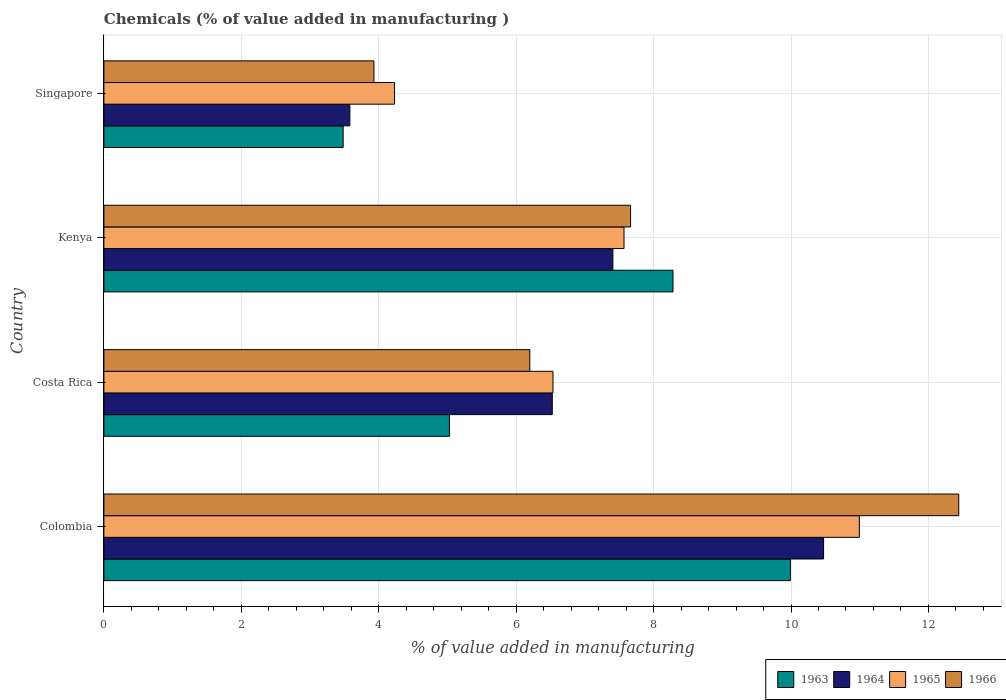How many bars are there on the 4th tick from the top?
Offer a terse response. 4. What is the label of the 2nd group of bars from the top?
Ensure brevity in your answer.  Kenya. In how many cases, is the number of bars for a given country not equal to the number of legend labels?
Your response must be concise. 0. What is the value added in manufacturing chemicals in 1965 in Colombia?
Offer a very short reply. 10.99. Across all countries, what is the maximum value added in manufacturing chemicals in 1964?
Ensure brevity in your answer.  10.47. Across all countries, what is the minimum value added in manufacturing chemicals in 1966?
Your answer should be compact. 3.93. In which country was the value added in manufacturing chemicals in 1965 maximum?
Your answer should be compact. Colombia. In which country was the value added in manufacturing chemicals in 1964 minimum?
Your response must be concise. Singapore. What is the total value added in manufacturing chemicals in 1964 in the graph?
Your answer should be very brief. 27.99. What is the difference between the value added in manufacturing chemicals in 1965 in Costa Rica and that in Singapore?
Your answer should be very brief. 2.31. What is the difference between the value added in manufacturing chemicals in 1963 in Kenya and the value added in manufacturing chemicals in 1965 in Singapore?
Offer a terse response. 4.05. What is the average value added in manufacturing chemicals in 1965 per country?
Ensure brevity in your answer.  7.33. What is the difference between the value added in manufacturing chemicals in 1963 and value added in manufacturing chemicals in 1965 in Kenya?
Ensure brevity in your answer.  0.71. In how many countries, is the value added in manufacturing chemicals in 1966 greater than 2.8 %?
Give a very brief answer. 4. What is the ratio of the value added in manufacturing chemicals in 1964 in Colombia to that in Kenya?
Offer a very short reply. 1.41. Is the value added in manufacturing chemicals in 1963 in Colombia less than that in Costa Rica?
Offer a very short reply. No. Is the difference between the value added in manufacturing chemicals in 1963 in Costa Rica and Singapore greater than the difference between the value added in manufacturing chemicals in 1965 in Costa Rica and Singapore?
Provide a succinct answer. No. What is the difference between the highest and the second highest value added in manufacturing chemicals in 1965?
Offer a very short reply. 3.43. What is the difference between the highest and the lowest value added in manufacturing chemicals in 1963?
Keep it short and to the point. 6.51. Is the sum of the value added in manufacturing chemicals in 1963 in Costa Rica and Kenya greater than the maximum value added in manufacturing chemicals in 1966 across all countries?
Give a very brief answer. Yes. Is it the case that in every country, the sum of the value added in manufacturing chemicals in 1965 and value added in manufacturing chemicals in 1963 is greater than the sum of value added in manufacturing chemicals in 1966 and value added in manufacturing chemicals in 1964?
Provide a succinct answer. No. What does the 1st bar from the top in Singapore represents?
Make the answer very short. 1966. What does the 2nd bar from the bottom in Kenya represents?
Offer a very short reply. 1964. Is it the case that in every country, the sum of the value added in manufacturing chemicals in 1966 and value added in manufacturing chemicals in 1964 is greater than the value added in manufacturing chemicals in 1965?
Your response must be concise. Yes. How many bars are there?
Ensure brevity in your answer.  16. Are all the bars in the graph horizontal?
Your response must be concise. Yes. How many countries are there in the graph?
Make the answer very short. 4. What is the difference between two consecutive major ticks on the X-axis?
Offer a very short reply. 2. Are the values on the major ticks of X-axis written in scientific E-notation?
Make the answer very short. No. Does the graph contain grids?
Make the answer very short. Yes. How many legend labels are there?
Provide a short and direct response. 4. How are the legend labels stacked?
Your response must be concise. Horizontal. What is the title of the graph?
Make the answer very short. Chemicals (% of value added in manufacturing ). What is the label or title of the X-axis?
Your answer should be very brief. % of value added in manufacturing. What is the % of value added in manufacturing of 1963 in Colombia?
Offer a very short reply. 9.99. What is the % of value added in manufacturing in 1964 in Colombia?
Your response must be concise. 10.47. What is the % of value added in manufacturing in 1965 in Colombia?
Your response must be concise. 10.99. What is the % of value added in manufacturing of 1966 in Colombia?
Offer a terse response. 12.44. What is the % of value added in manufacturing of 1963 in Costa Rica?
Offer a very short reply. 5.03. What is the % of value added in manufacturing of 1964 in Costa Rica?
Provide a succinct answer. 6.53. What is the % of value added in manufacturing in 1965 in Costa Rica?
Your answer should be compact. 6.54. What is the % of value added in manufacturing in 1966 in Costa Rica?
Provide a short and direct response. 6.2. What is the % of value added in manufacturing in 1963 in Kenya?
Give a very brief answer. 8.28. What is the % of value added in manufacturing of 1964 in Kenya?
Provide a short and direct response. 7.41. What is the % of value added in manufacturing of 1965 in Kenya?
Offer a very short reply. 7.57. What is the % of value added in manufacturing in 1966 in Kenya?
Keep it short and to the point. 7.67. What is the % of value added in manufacturing of 1963 in Singapore?
Make the answer very short. 3.48. What is the % of value added in manufacturing of 1964 in Singapore?
Your answer should be compact. 3.58. What is the % of value added in manufacturing in 1965 in Singapore?
Give a very brief answer. 4.23. What is the % of value added in manufacturing in 1966 in Singapore?
Your answer should be compact. 3.93. Across all countries, what is the maximum % of value added in manufacturing of 1963?
Provide a succinct answer. 9.99. Across all countries, what is the maximum % of value added in manufacturing in 1964?
Your response must be concise. 10.47. Across all countries, what is the maximum % of value added in manufacturing in 1965?
Your answer should be very brief. 10.99. Across all countries, what is the maximum % of value added in manufacturing in 1966?
Your answer should be compact. 12.44. Across all countries, what is the minimum % of value added in manufacturing of 1963?
Keep it short and to the point. 3.48. Across all countries, what is the minimum % of value added in manufacturing in 1964?
Keep it short and to the point. 3.58. Across all countries, what is the minimum % of value added in manufacturing in 1965?
Provide a short and direct response. 4.23. Across all countries, what is the minimum % of value added in manufacturing in 1966?
Keep it short and to the point. 3.93. What is the total % of value added in manufacturing in 1963 in the graph?
Make the answer very short. 26.79. What is the total % of value added in manufacturing in 1964 in the graph?
Make the answer very short. 27.99. What is the total % of value added in manufacturing in 1965 in the graph?
Offer a very short reply. 29.33. What is the total % of value added in manufacturing in 1966 in the graph?
Ensure brevity in your answer.  30.23. What is the difference between the % of value added in manufacturing of 1963 in Colombia and that in Costa Rica?
Ensure brevity in your answer.  4.96. What is the difference between the % of value added in manufacturing of 1964 in Colombia and that in Costa Rica?
Offer a terse response. 3.95. What is the difference between the % of value added in manufacturing of 1965 in Colombia and that in Costa Rica?
Your response must be concise. 4.46. What is the difference between the % of value added in manufacturing of 1966 in Colombia and that in Costa Rica?
Give a very brief answer. 6.24. What is the difference between the % of value added in manufacturing of 1963 in Colombia and that in Kenya?
Your answer should be very brief. 1.71. What is the difference between the % of value added in manufacturing of 1964 in Colombia and that in Kenya?
Provide a short and direct response. 3.07. What is the difference between the % of value added in manufacturing in 1965 in Colombia and that in Kenya?
Your answer should be compact. 3.43. What is the difference between the % of value added in manufacturing of 1966 in Colombia and that in Kenya?
Make the answer very short. 4.78. What is the difference between the % of value added in manufacturing of 1963 in Colombia and that in Singapore?
Give a very brief answer. 6.51. What is the difference between the % of value added in manufacturing of 1964 in Colombia and that in Singapore?
Your answer should be very brief. 6.89. What is the difference between the % of value added in manufacturing in 1965 in Colombia and that in Singapore?
Your response must be concise. 6.76. What is the difference between the % of value added in manufacturing in 1966 in Colombia and that in Singapore?
Provide a succinct answer. 8.51. What is the difference between the % of value added in manufacturing of 1963 in Costa Rica and that in Kenya?
Offer a terse response. -3.25. What is the difference between the % of value added in manufacturing in 1964 in Costa Rica and that in Kenya?
Offer a very short reply. -0.88. What is the difference between the % of value added in manufacturing of 1965 in Costa Rica and that in Kenya?
Provide a succinct answer. -1.03. What is the difference between the % of value added in manufacturing in 1966 in Costa Rica and that in Kenya?
Provide a short and direct response. -1.47. What is the difference between the % of value added in manufacturing in 1963 in Costa Rica and that in Singapore?
Ensure brevity in your answer.  1.55. What is the difference between the % of value added in manufacturing in 1964 in Costa Rica and that in Singapore?
Offer a terse response. 2.95. What is the difference between the % of value added in manufacturing of 1965 in Costa Rica and that in Singapore?
Provide a short and direct response. 2.31. What is the difference between the % of value added in manufacturing of 1966 in Costa Rica and that in Singapore?
Ensure brevity in your answer.  2.27. What is the difference between the % of value added in manufacturing of 1963 in Kenya and that in Singapore?
Your answer should be compact. 4.8. What is the difference between the % of value added in manufacturing in 1964 in Kenya and that in Singapore?
Ensure brevity in your answer.  3.83. What is the difference between the % of value added in manufacturing of 1965 in Kenya and that in Singapore?
Your response must be concise. 3.34. What is the difference between the % of value added in manufacturing in 1966 in Kenya and that in Singapore?
Your response must be concise. 3.74. What is the difference between the % of value added in manufacturing of 1963 in Colombia and the % of value added in manufacturing of 1964 in Costa Rica?
Your response must be concise. 3.47. What is the difference between the % of value added in manufacturing of 1963 in Colombia and the % of value added in manufacturing of 1965 in Costa Rica?
Your answer should be very brief. 3.46. What is the difference between the % of value added in manufacturing in 1963 in Colombia and the % of value added in manufacturing in 1966 in Costa Rica?
Your answer should be compact. 3.79. What is the difference between the % of value added in manufacturing in 1964 in Colombia and the % of value added in manufacturing in 1965 in Costa Rica?
Keep it short and to the point. 3.94. What is the difference between the % of value added in manufacturing in 1964 in Colombia and the % of value added in manufacturing in 1966 in Costa Rica?
Provide a succinct answer. 4.28. What is the difference between the % of value added in manufacturing of 1965 in Colombia and the % of value added in manufacturing of 1966 in Costa Rica?
Provide a short and direct response. 4.8. What is the difference between the % of value added in manufacturing of 1963 in Colombia and the % of value added in manufacturing of 1964 in Kenya?
Your response must be concise. 2.58. What is the difference between the % of value added in manufacturing in 1963 in Colombia and the % of value added in manufacturing in 1965 in Kenya?
Keep it short and to the point. 2.42. What is the difference between the % of value added in manufacturing in 1963 in Colombia and the % of value added in manufacturing in 1966 in Kenya?
Offer a very short reply. 2.33. What is the difference between the % of value added in manufacturing of 1964 in Colombia and the % of value added in manufacturing of 1965 in Kenya?
Provide a short and direct response. 2.9. What is the difference between the % of value added in manufacturing of 1964 in Colombia and the % of value added in manufacturing of 1966 in Kenya?
Your answer should be compact. 2.81. What is the difference between the % of value added in manufacturing in 1965 in Colombia and the % of value added in manufacturing in 1966 in Kenya?
Offer a very short reply. 3.33. What is the difference between the % of value added in manufacturing of 1963 in Colombia and the % of value added in manufacturing of 1964 in Singapore?
Provide a short and direct response. 6.41. What is the difference between the % of value added in manufacturing in 1963 in Colombia and the % of value added in manufacturing in 1965 in Singapore?
Keep it short and to the point. 5.76. What is the difference between the % of value added in manufacturing of 1963 in Colombia and the % of value added in manufacturing of 1966 in Singapore?
Make the answer very short. 6.06. What is the difference between the % of value added in manufacturing of 1964 in Colombia and the % of value added in manufacturing of 1965 in Singapore?
Your answer should be compact. 6.24. What is the difference between the % of value added in manufacturing in 1964 in Colombia and the % of value added in manufacturing in 1966 in Singapore?
Ensure brevity in your answer.  6.54. What is the difference between the % of value added in manufacturing in 1965 in Colombia and the % of value added in manufacturing in 1966 in Singapore?
Ensure brevity in your answer.  7.07. What is the difference between the % of value added in manufacturing of 1963 in Costa Rica and the % of value added in manufacturing of 1964 in Kenya?
Ensure brevity in your answer.  -2.38. What is the difference between the % of value added in manufacturing of 1963 in Costa Rica and the % of value added in manufacturing of 1965 in Kenya?
Offer a terse response. -2.54. What is the difference between the % of value added in manufacturing in 1963 in Costa Rica and the % of value added in manufacturing in 1966 in Kenya?
Make the answer very short. -2.64. What is the difference between the % of value added in manufacturing in 1964 in Costa Rica and the % of value added in manufacturing in 1965 in Kenya?
Provide a short and direct response. -1.04. What is the difference between the % of value added in manufacturing of 1964 in Costa Rica and the % of value added in manufacturing of 1966 in Kenya?
Keep it short and to the point. -1.14. What is the difference between the % of value added in manufacturing in 1965 in Costa Rica and the % of value added in manufacturing in 1966 in Kenya?
Make the answer very short. -1.13. What is the difference between the % of value added in manufacturing of 1963 in Costa Rica and the % of value added in manufacturing of 1964 in Singapore?
Ensure brevity in your answer.  1.45. What is the difference between the % of value added in manufacturing of 1963 in Costa Rica and the % of value added in manufacturing of 1965 in Singapore?
Provide a short and direct response. 0.8. What is the difference between the % of value added in manufacturing in 1963 in Costa Rica and the % of value added in manufacturing in 1966 in Singapore?
Your response must be concise. 1.1. What is the difference between the % of value added in manufacturing of 1964 in Costa Rica and the % of value added in manufacturing of 1965 in Singapore?
Your answer should be very brief. 2.3. What is the difference between the % of value added in manufacturing of 1964 in Costa Rica and the % of value added in manufacturing of 1966 in Singapore?
Keep it short and to the point. 2.6. What is the difference between the % of value added in manufacturing of 1965 in Costa Rica and the % of value added in manufacturing of 1966 in Singapore?
Provide a succinct answer. 2.61. What is the difference between the % of value added in manufacturing in 1963 in Kenya and the % of value added in manufacturing in 1964 in Singapore?
Make the answer very short. 4.7. What is the difference between the % of value added in manufacturing of 1963 in Kenya and the % of value added in manufacturing of 1965 in Singapore?
Offer a terse response. 4.05. What is the difference between the % of value added in manufacturing of 1963 in Kenya and the % of value added in manufacturing of 1966 in Singapore?
Give a very brief answer. 4.35. What is the difference between the % of value added in manufacturing of 1964 in Kenya and the % of value added in manufacturing of 1965 in Singapore?
Offer a terse response. 3.18. What is the difference between the % of value added in manufacturing of 1964 in Kenya and the % of value added in manufacturing of 1966 in Singapore?
Keep it short and to the point. 3.48. What is the difference between the % of value added in manufacturing of 1965 in Kenya and the % of value added in manufacturing of 1966 in Singapore?
Make the answer very short. 3.64. What is the average % of value added in manufacturing in 1963 per country?
Provide a succinct answer. 6.7. What is the average % of value added in manufacturing of 1964 per country?
Give a very brief answer. 7. What is the average % of value added in manufacturing of 1965 per country?
Provide a short and direct response. 7.33. What is the average % of value added in manufacturing of 1966 per country?
Offer a very short reply. 7.56. What is the difference between the % of value added in manufacturing of 1963 and % of value added in manufacturing of 1964 in Colombia?
Your answer should be very brief. -0.48. What is the difference between the % of value added in manufacturing in 1963 and % of value added in manufacturing in 1965 in Colombia?
Your response must be concise. -1. What is the difference between the % of value added in manufacturing in 1963 and % of value added in manufacturing in 1966 in Colombia?
Your answer should be very brief. -2.45. What is the difference between the % of value added in manufacturing of 1964 and % of value added in manufacturing of 1965 in Colombia?
Your response must be concise. -0.52. What is the difference between the % of value added in manufacturing of 1964 and % of value added in manufacturing of 1966 in Colombia?
Keep it short and to the point. -1.97. What is the difference between the % of value added in manufacturing in 1965 and % of value added in manufacturing in 1966 in Colombia?
Your response must be concise. -1.45. What is the difference between the % of value added in manufacturing in 1963 and % of value added in manufacturing in 1964 in Costa Rica?
Provide a succinct answer. -1.5. What is the difference between the % of value added in manufacturing in 1963 and % of value added in manufacturing in 1965 in Costa Rica?
Provide a succinct answer. -1.51. What is the difference between the % of value added in manufacturing in 1963 and % of value added in manufacturing in 1966 in Costa Rica?
Provide a succinct answer. -1.17. What is the difference between the % of value added in manufacturing of 1964 and % of value added in manufacturing of 1965 in Costa Rica?
Your answer should be compact. -0.01. What is the difference between the % of value added in manufacturing in 1964 and % of value added in manufacturing in 1966 in Costa Rica?
Give a very brief answer. 0.33. What is the difference between the % of value added in manufacturing in 1965 and % of value added in manufacturing in 1966 in Costa Rica?
Keep it short and to the point. 0.34. What is the difference between the % of value added in manufacturing in 1963 and % of value added in manufacturing in 1964 in Kenya?
Your answer should be compact. 0.87. What is the difference between the % of value added in manufacturing in 1963 and % of value added in manufacturing in 1965 in Kenya?
Keep it short and to the point. 0.71. What is the difference between the % of value added in manufacturing in 1963 and % of value added in manufacturing in 1966 in Kenya?
Offer a very short reply. 0.62. What is the difference between the % of value added in manufacturing of 1964 and % of value added in manufacturing of 1965 in Kenya?
Provide a succinct answer. -0.16. What is the difference between the % of value added in manufacturing in 1964 and % of value added in manufacturing in 1966 in Kenya?
Ensure brevity in your answer.  -0.26. What is the difference between the % of value added in manufacturing in 1965 and % of value added in manufacturing in 1966 in Kenya?
Offer a terse response. -0.1. What is the difference between the % of value added in manufacturing of 1963 and % of value added in manufacturing of 1964 in Singapore?
Give a very brief answer. -0.1. What is the difference between the % of value added in manufacturing in 1963 and % of value added in manufacturing in 1965 in Singapore?
Keep it short and to the point. -0.75. What is the difference between the % of value added in manufacturing in 1963 and % of value added in manufacturing in 1966 in Singapore?
Offer a very short reply. -0.45. What is the difference between the % of value added in manufacturing of 1964 and % of value added in manufacturing of 1965 in Singapore?
Keep it short and to the point. -0.65. What is the difference between the % of value added in manufacturing of 1964 and % of value added in manufacturing of 1966 in Singapore?
Your answer should be compact. -0.35. What is the difference between the % of value added in manufacturing in 1965 and % of value added in manufacturing in 1966 in Singapore?
Provide a succinct answer. 0.3. What is the ratio of the % of value added in manufacturing in 1963 in Colombia to that in Costa Rica?
Give a very brief answer. 1.99. What is the ratio of the % of value added in manufacturing in 1964 in Colombia to that in Costa Rica?
Make the answer very short. 1.61. What is the ratio of the % of value added in manufacturing in 1965 in Colombia to that in Costa Rica?
Your answer should be very brief. 1.68. What is the ratio of the % of value added in manufacturing of 1966 in Colombia to that in Costa Rica?
Make the answer very short. 2.01. What is the ratio of the % of value added in manufacturing in 1963 in Colombia to that in Kenya?
Your response must be concise. 1.21. What is the ratio of the % of value added in manufacturing of 1964 in Colombia to that in Kenya?
Ensure brevity in your answer.  1.41. What is the ratio of the % of value added in manufacturing of 1965 in Colombia to that in Kenya?
Your answer should be very brief. 1.45. What is the ratio of the % of value added in manufacturing of 1966 in Colombia to that in Kenya?
Make the answer very short. 1.62. What is the ratio of the % of value added in manufacturing of 1963 in Colombia to that in Singapore?
Offer a very short reply. 2.87. What is the ratio of the % of value added in manufacturing of 1964 in Colombia to that in Singapore?
Provide a short and direct response. 2.93. What is the ratio of the % of value added in manufacturing in 1965 in Colombia to that in Singapore?
Offer a very short reply. 2.6. What is the ratio of the % of value added in manufacturing in 1966 in Colombia to that in Singapore?
Your response must be concise. 3.17. What is the ratio of the % of value added in manufacturing in 1963 in Costa Rica to that in Kenya?
Your response must be concise. 0.61. What is the ratio of the % of value added in manufacturing of 1964 in Costa Rica to that in Kenya?
Make the answer very short. 0.88. What is the ratio of the % of value added in manufacturing of 1965 in Costa Rica to that in Kenya?
Keep it short and to the point. 0.86. What is the ratio of the % of value added in manufacturing of 1966 in Costa Rica to that in Kenya?
Provide a succinct answer. 0.81. What is the ratio of the % of value added in manufacturing of 1963 in Costa Rica to that in Singapore?
Make the answer very short. 1.44. What is the ratio of the % of value added in manufacturing in 1964 in Costa Rica to that in Singapore?
Make the answer very short. 1.82. What is the ratio of the % of value added in manufacturing of 1965 in Costa Rica to that in Singapore?
Make the answer very short. 1.55. What is the ratio of the % of value added in manufacturing in 1966 in Costa Rica to that in Singapore?
Give a very brief answer. 1.58. What is the ratio of the % of value added in manufacturing of 1963 in Kenya to that in Singapore?
Make the answer very short. 2.38. What is the ratio of the % of value added in manufacturing in 1964 in Kenya to that in Singapore?
Make the answer very short. 2.07. What is the ratio of the % of value added in manufacturing in 1965 in Kenya to that in Singapore?
Your response must be concise. 1.79. What is the ratio of the % of value added in manufacturing in 1966 in Kenya to that in Singapore?
Your answer should be very brief. 1.95. What is the difference between the highest and the second highest % of value added in manufacturing of 1963?
Ensure brevity in your answer.  1.71. What is the difference between the highest and the second highest % of value added in manufacturing of 1964?
Provide a succinct answer. 3.07. What is the difference between the highest and the second highest % of value added in manufacturing of 1965?
Your answer should be very brief. 3.43. What is the difference between the highest and the second highest % of value added in manufacturing of 1966?
Ensure brevity in your answer.  4.78. What is the difference between the highest and the lowest % of value added in manufacturing in 1963?
Your answer should be very brief. 6.51. What is the difference between the highest and the lowest % of value added in manufacturing of 1964?
Offer a terse response. 6.89. What is the difference between the highest and the lowest % of value added in manufacturing of 1965?
Give a very brief answer. 6.76. What is the difference between the highest and the lowest % of value added in manufacturing of 1966?
Ensure brevity in your answer.  8.51. 